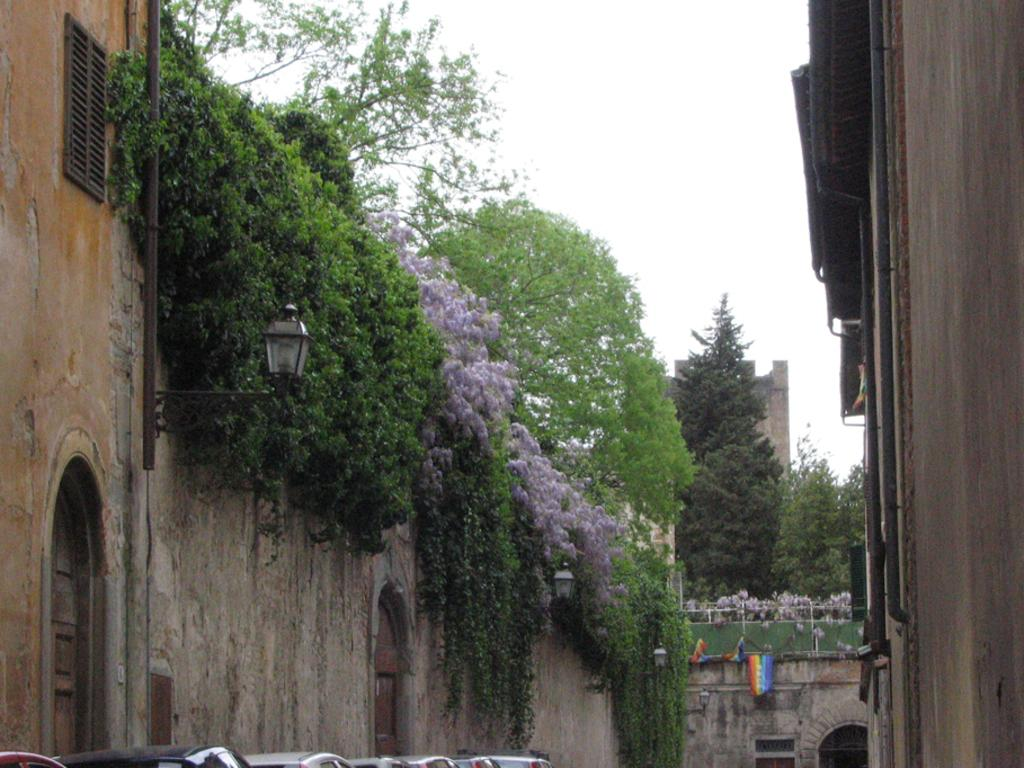What type of structures can be seen in the image? There are buildings in the image. What natural elements are present in the image? There are trees and plants in the image. What man-made objects can be seen in the image? There are flags and cars in the image. What type of illumination is present on the wall in the image? There are lights on the wall in the image. What is the condition of the sky in the image? The sky is cloudy in the image. What type of button can be seen on the ice in the image? There is no button or ice present in the image. What color is the smoke coming out of the chimney in the image? There is no smoke or chimney present in the image. 